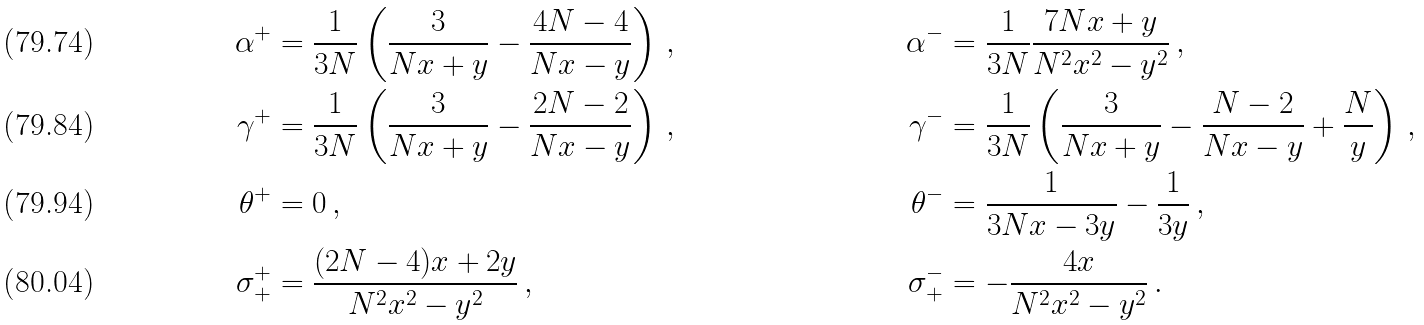<formula> <loc_0><loc_0><loc_500><loc_500>\alpha ^ { + } & = \frac { 1 } { 3 N } \left ( \frac { 3 } { N x + y } - \frac { 4 N - 4 } { N x - y } \right ) \, , & \alpha ^ { - } & = \frac { 1 } { 3 N } \frac { 7 N x + y } { N ^ { 2 } x ^ { 2 } - y ^ { 2 } } \, , \\ \gamma ^ { + } & = \frac { 1 } { 3 N } \left ( \frac { 3 } { N x + y } - \frac { 2 N - 2 } { N x - y } \right ) \, , & \gamma ^ { - } & = \frac { 1 } { 3 N } \left ( \frac { 3 } { N x + y } - \frac { N - 2 } { N x - y } + \frac { N } { y } \right ) \, , \\ \theta ^ { + } & = 0 \, , & \theta ^ { - } & = \frac { 1 } { 3 N x - 3 y } - \frac { 1 } { 3 y } \, , \\ \sigma _ { + } ^ { + } & = \frac { ( 2 N - 4 ) x + 2 y } { N ^ { 2 } x ^ { 2 } - y ^ { 2 } } \, , & \sigma _ { + } ^ { - } & = - \frac { 4 x } { N ^ { 2 } x ^ { 2 } - y ^ { 2 } } \, .</formula> 